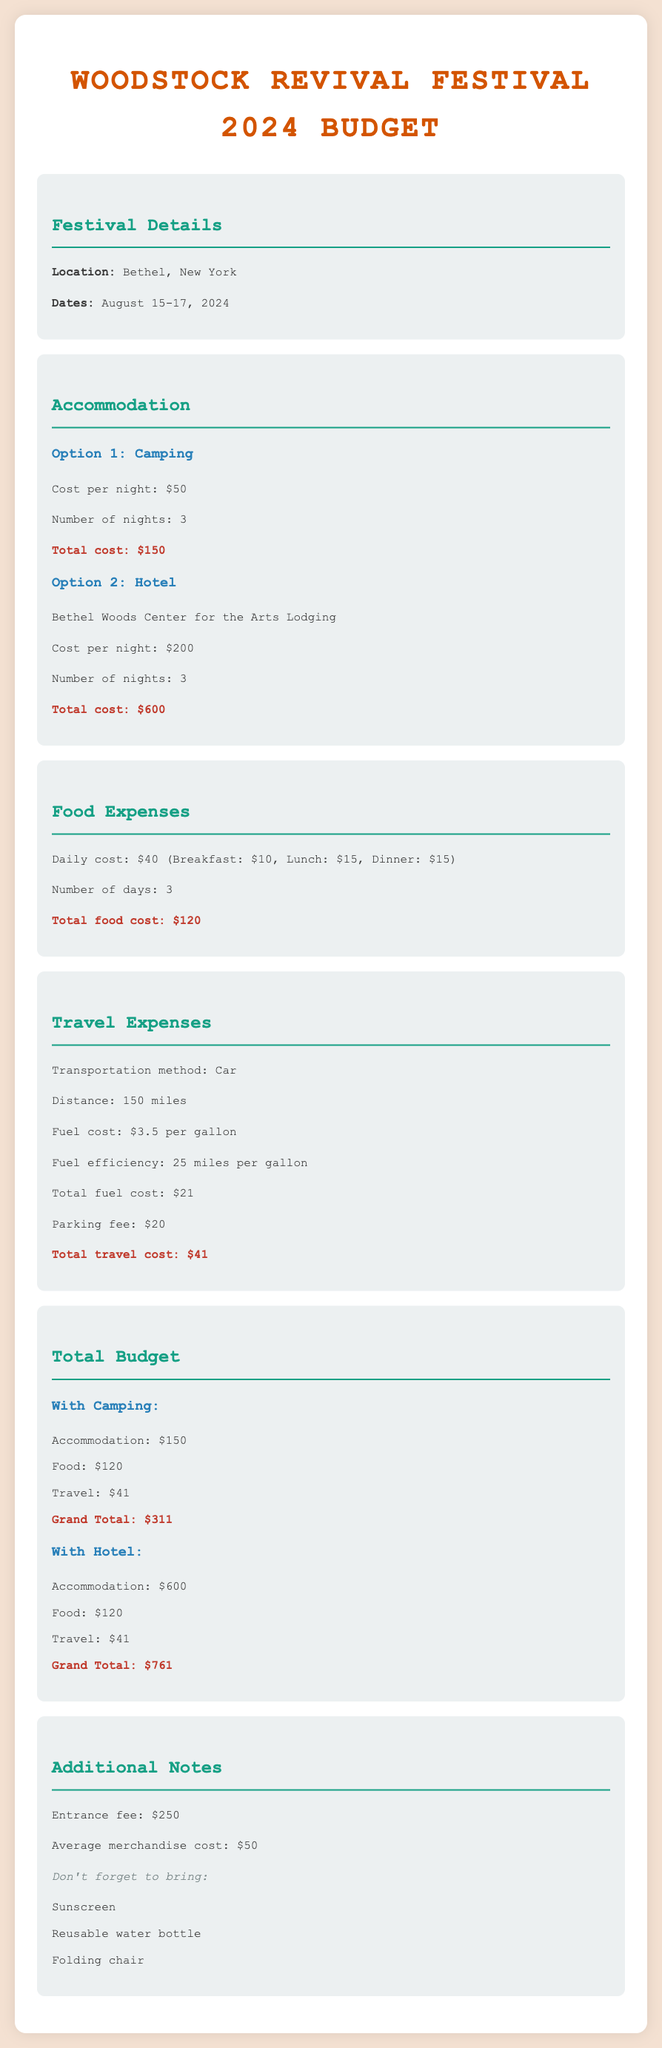What are the dates of the festival? The dates of the festival are August 15-17, 2024, as mentioned in the festival details.
Answer: August 15-17, 2024 What is the camping cost per night? The camping cost per night is listed as $50 in the accommodation section.
Answer: $50 How many nights will the hotel stay cost? The hotel stay cost is calculated for 3 nights, as indicated under the hotel section of accommodation.
Answer: 3 What is the total food cost? The total food cost is provided as the sum for three days at $40 per day, which equals $120.
Answer: $120 What is the total travel cost with camping? The total travel cost with camping is calculated in the budget section, amounting to $41.
Answer: $41 What is the grand total with hotel accommodation? The grand total with hotel accommodation is highlighted as $761 in the budget section.
Answer: $761 What is the entrance fee for the festival? The entrance fee is explicitly stated as $250 in the additional notes section.
Answer: $250 What is the average merchandise cost? The average merchandise cost is shown as $50 included in the additional notes.
Answer: $50 What should you bring to the festival? The items listed under "Don't forget to bring" serve as suggestions for attendees and include sunscreen, reusable water bottle, and folding chair.
Answer: Sunscreen, reusable water bottle, folding chair 